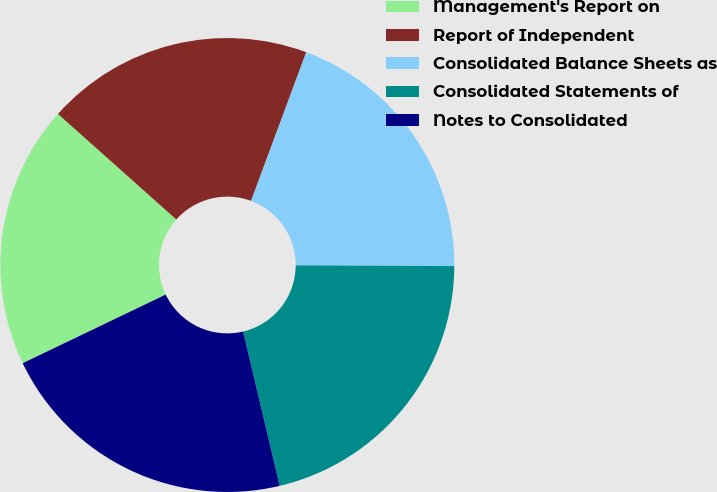Convert chart. <chart><loc_0><loc_0><loc_500><loc_500><pie_chart><fcel>Management's Report on<fcel>Report of Independent<fcel>Consolidated Balance Sheets as<fcel>Consolidated Statements of<fcel>Notes to Consolidated<nl><fcel>18.71%<fcel>19.06%<fcel>19.42%<fcel>21.22%<fcel>21.58%<nl></chart> 